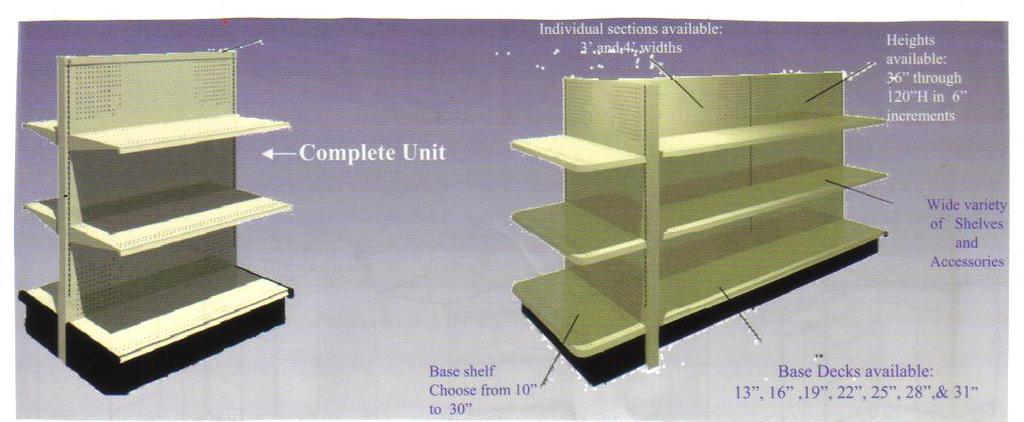What is shown on the left?
Give a very brief answer. Complete unit. 